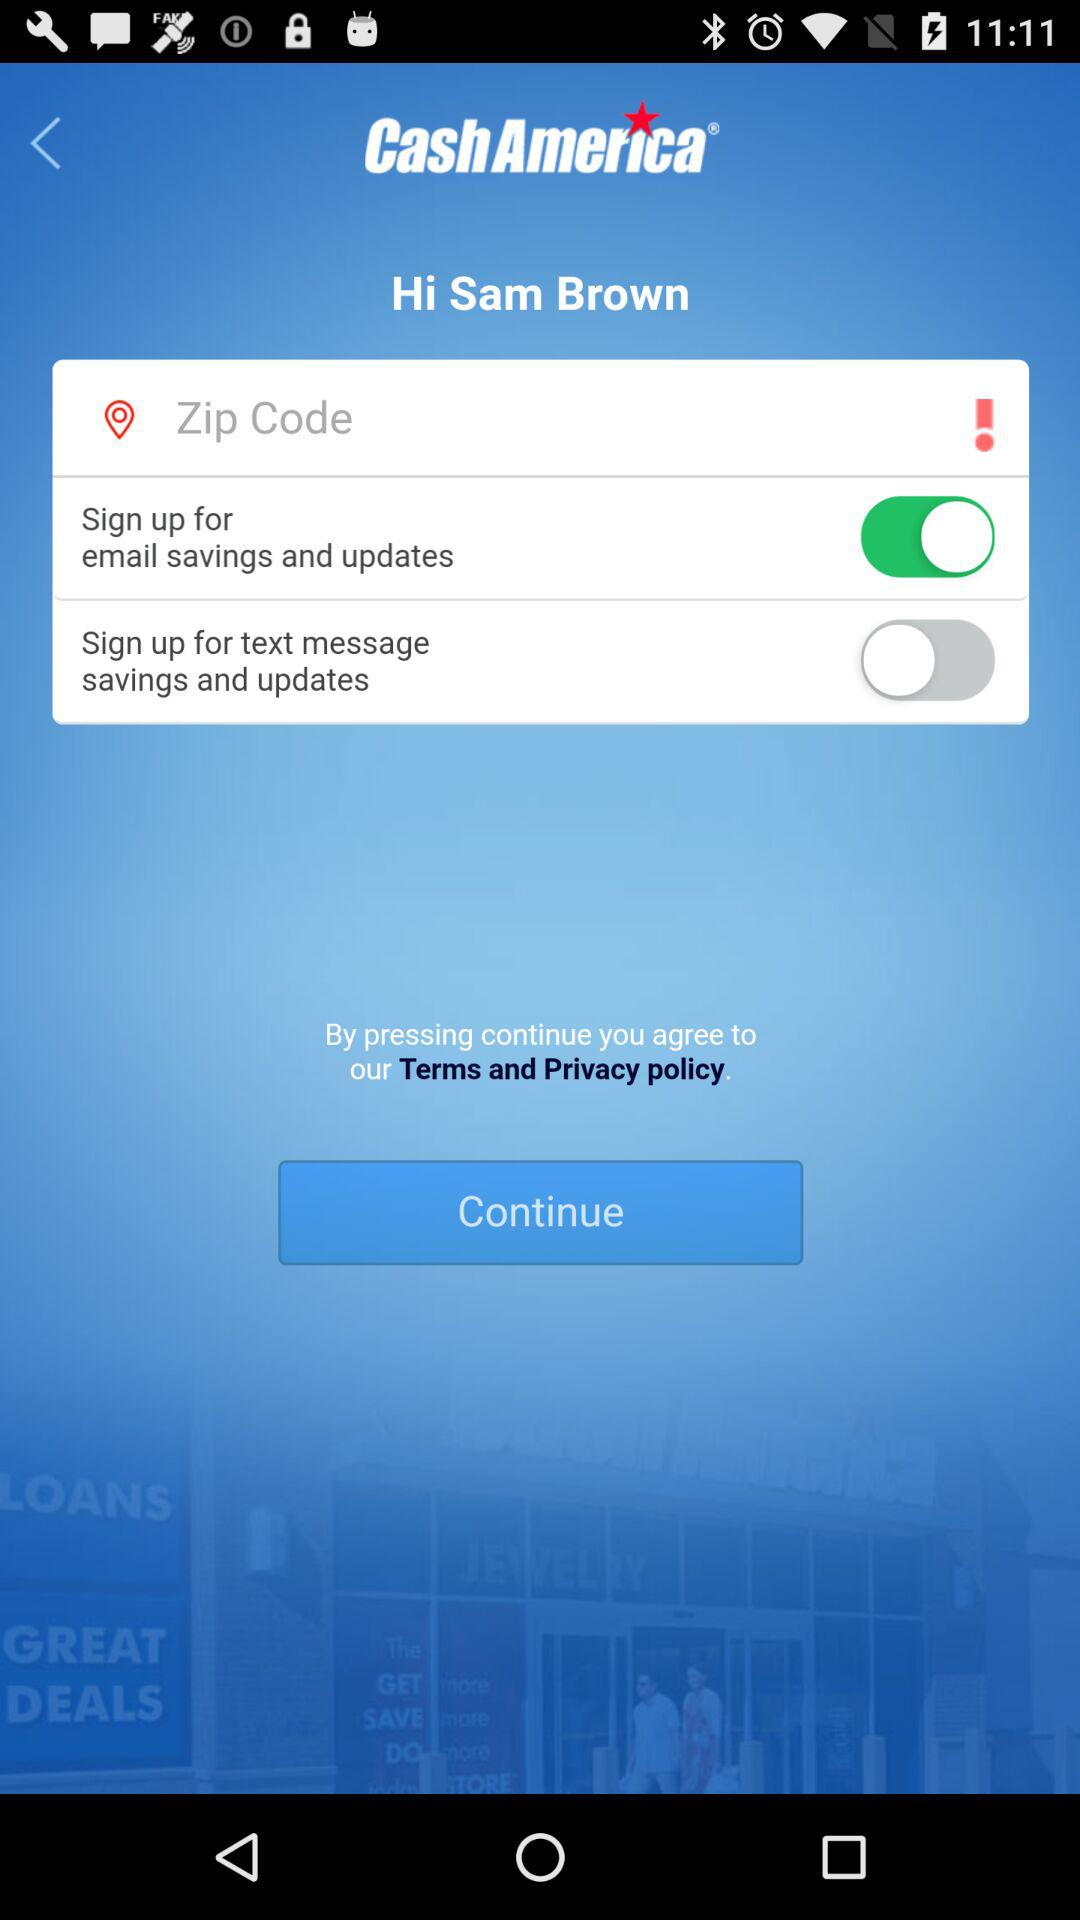How many text message switches are there?
Answer the question using a single word or phrase. 1 